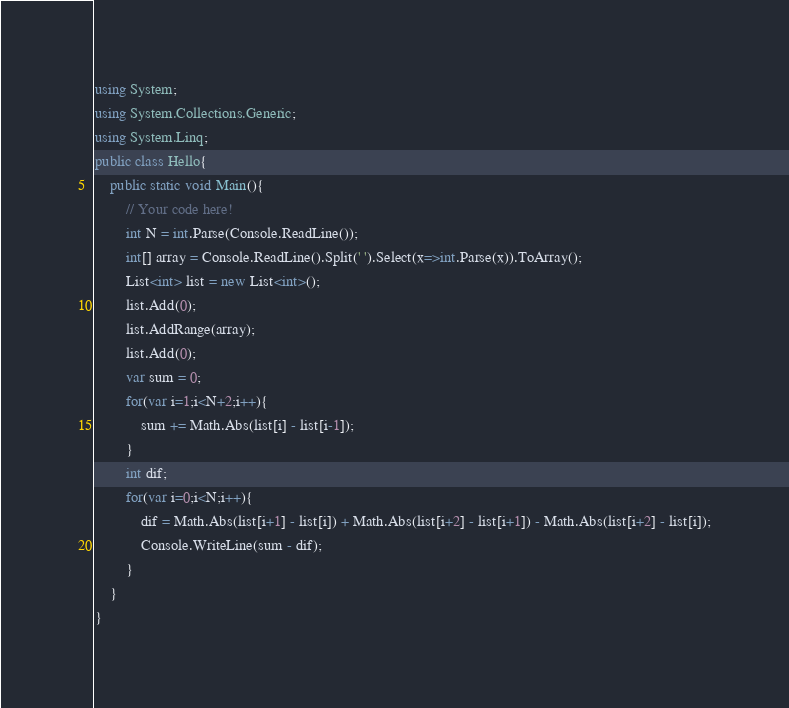<code> <loc_0><loc_0><loc_500><loc_500><_C#_>using System;
using System.Collections.Generic;
using System.Linq;
public class Hello{
    public static void Main(){
        // Your code here!
        int N = int.Parse(Console.ReadLine());
        int[] array = Console.ReadLine().Split(' ').Select(x=>int.Parse(x)).ToArray();
        List<int> list = new List<int>();
        list.Add(0);
        list.AddRange(array);
        list.Add(0);
        var sum = 0;
        for(var i=1;i<N+2;i++){
            sum += Math.Abs(list[i] - list[i-1]);
        }
        int dif;
        for(var i=0;i<N;i++){
            dif = Math.Abs(list[i+1] - list[i]) + Math.Abs(list[i+2] - list[i+1]) - Math.Abs(list[i+2] - list[i]);
            Console.WriteLine(sum - dif);
        }
    }
}
</code> 